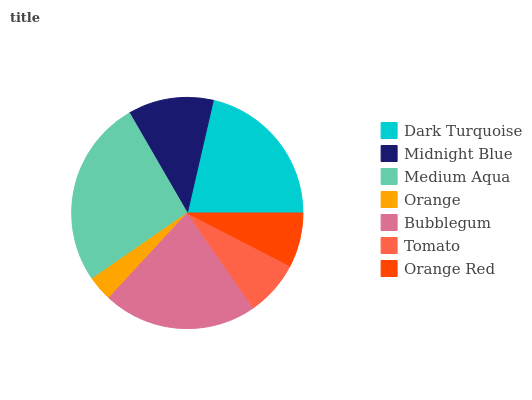Is Orange the minimum?
Answer yes or no. Yes. Is Medium Aqua the maximum?
Answer yes or no. Yes. Is Midnight Blue the minimum?
Answer yes or no. No. Is Midnight Blue the maximum?
Answer yes or no. No. Is Dark Turquoise greater than Midnight Blue?
Answer yes or no. Yes. Is Midnight Blue less than Dark Turquoise?
Answer yes or no. Yes. Is Midnight Blue greater than Dark Turquoise?
Answer yes or no. No. Is Dark Turquoise less than Midnight Blue?
Answer yes or no. No. Is Midnight Blue the high median?
Answer yes or no. Yes. Is Midnight Blue the low median?
Answer yes or no. Yes. Is Orange the high median?
Answer yes or no. No. Is Tomato the low median?
Answer yes or no. No. 